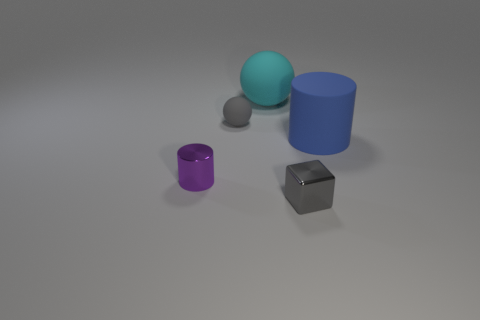Is there anything else that is the same size as the cyan thing?
Offer a terse response. Yes. Do the purple thing and the cyan rubber object have the same size?
Your answer should be compact. No. Is there a big brown shiny object?
Keep it short and to the point. No. Is there a big cyan object that has the same material as the tiny gray sphere?
Provide a succinct answer. Yes. There is a ball that is the same size as the blue rubber cylinder; what is it made of?
Offer a very short reply. Rubber. How many gray metal things have the same shape as the tiny gray rubber thing?
Keep it short and to the point. 0. There is a purple cylinder that is the same material as the cube; what is its size?
Ensure brevity in your answer.  Small. The small object that is both in front of the large blue matte cylinder and on the left side of the gray block is made of what material?
Your answer should be compact. Metal. What number of cubes have the same size as the cyan ball?
Offer a very short reply. 0. There is a purple thing that is the same shape as the blue object; what material is it?
Ensure brevity in your answer.  Metal. 